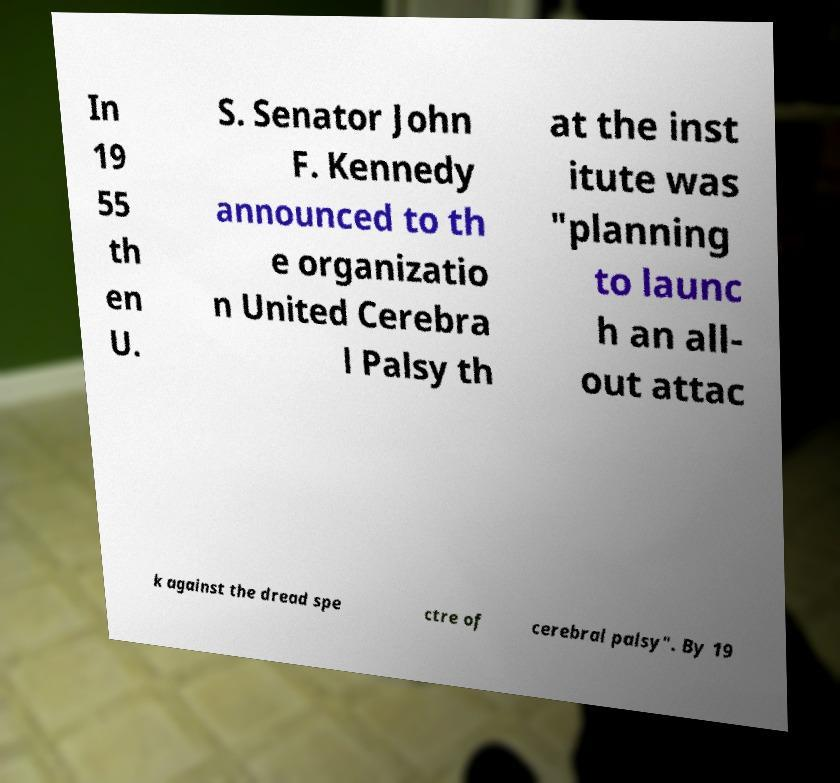Please read and relay the text visible in this image. What does it say? In 19 55 th en U. S. Senator John F. Kennedy announced to th e organizatio n United Cerebra l Palsy th at the inst itute was "planning to launc h an all- out attac k against the dread spe ctre of cerebral palsy". By 19 